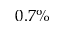Convert formula to latex. <formula><loc_0><loc_0><loc_500><loc_500>0 . 7 \%</formula> 